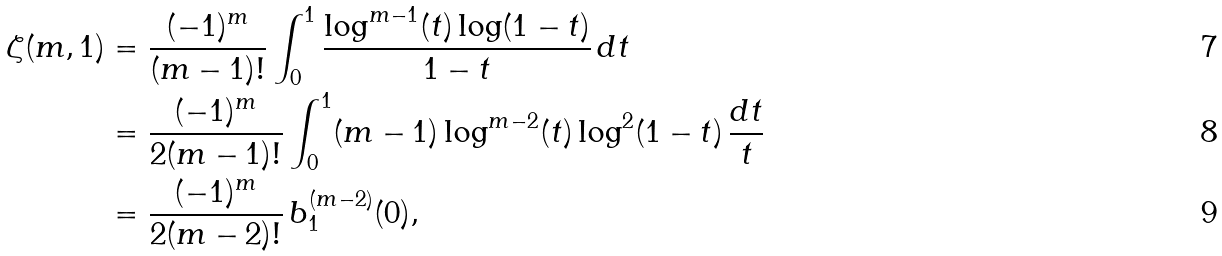<formula> <loc_0><loc_0><loc_500><loc_500>\zeta ( m , 1 ) & = \frac { ( - 1 ) ^ { m } } { ( m - 1 ) ! } \int _ { 0 } ^ { 1 } \frac { \log ^ { m - 1 } ( t ) \log ( 1 - t ) } { 1 - t } \, d t \\ & = \frac { ( - 1 ) ^ { m } } { 2 ( m - 1 ) ! } \int _ { 0 } ^ { 1 } ( m - 1 ) \log ^ { m - 2 } ( t ) \log ^ { 2 } ( 1 - t ) \, \frac { d t } { t } \\ & = \frac { ( - 1 ) ^ { m } } { 2 ( m - 2 ) ! } \, b _ { 1 } ^ { ( m - 2 ) } ( 0 ) ,</formula> 